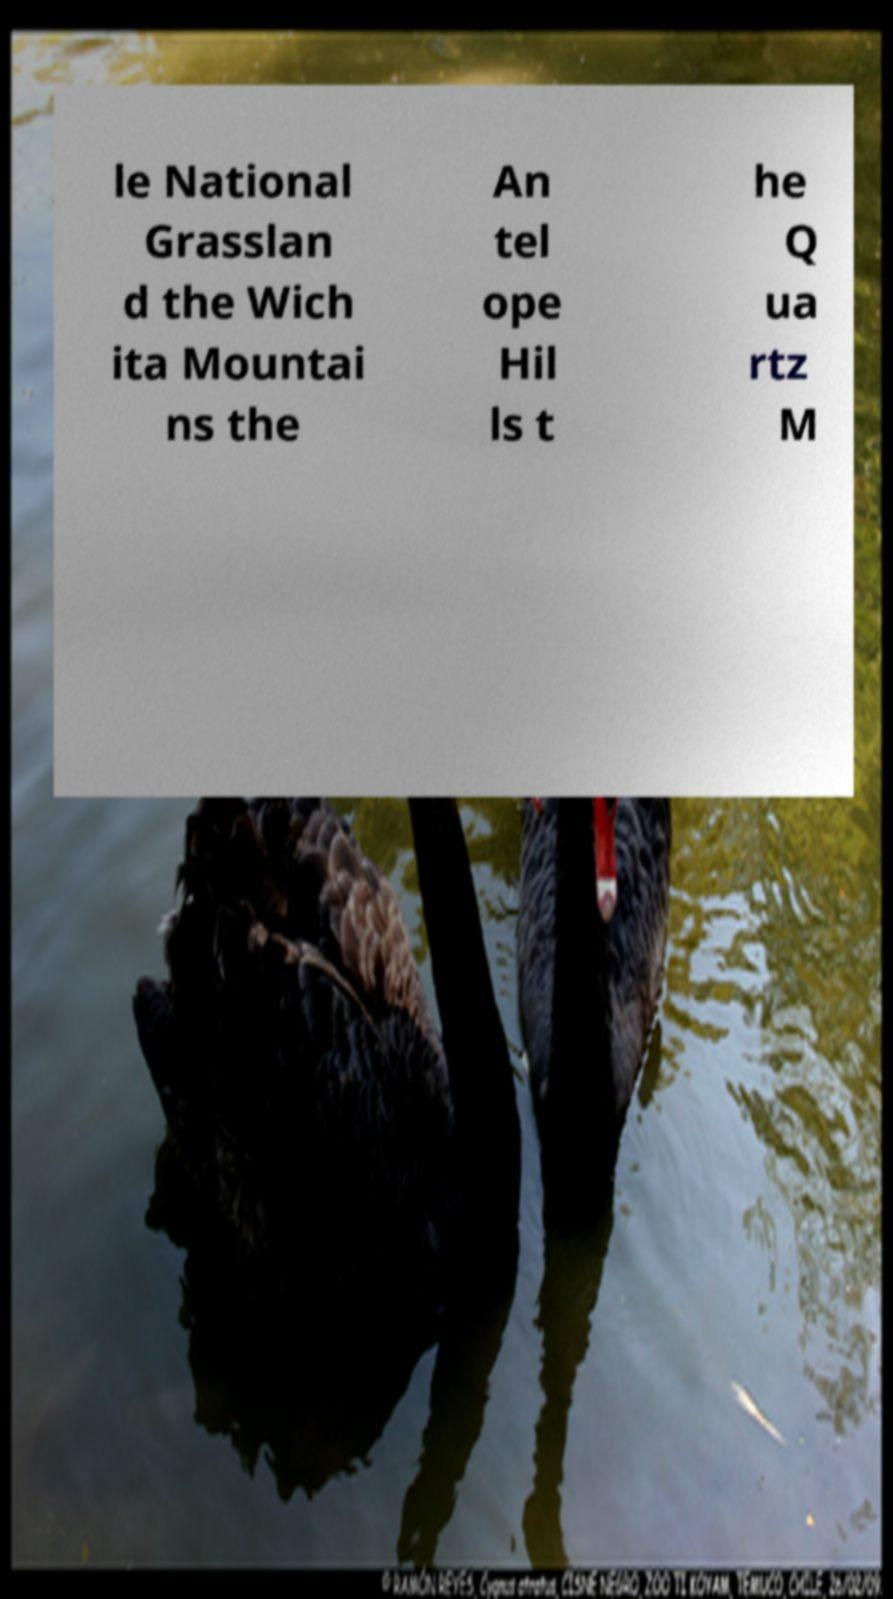Could you extract and type out the text from this image? le National Grasslan d the Wich ita Mountai ns the An tel ope Hil ls t he Q ua rtz M 